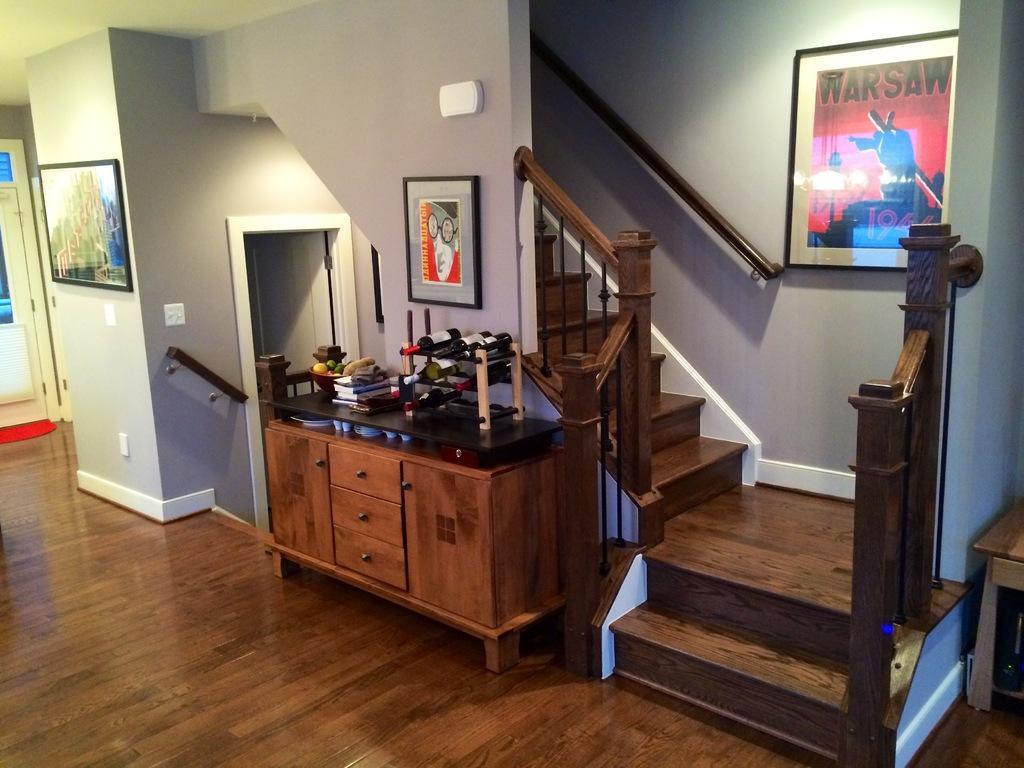Please provide a concise description of this image. The image is taken inside a house. There are photo frames which are attached to a wall. There is a door. There is a counter table. There is a mat placed on the floor. There are steps. On the right side there is a table. 